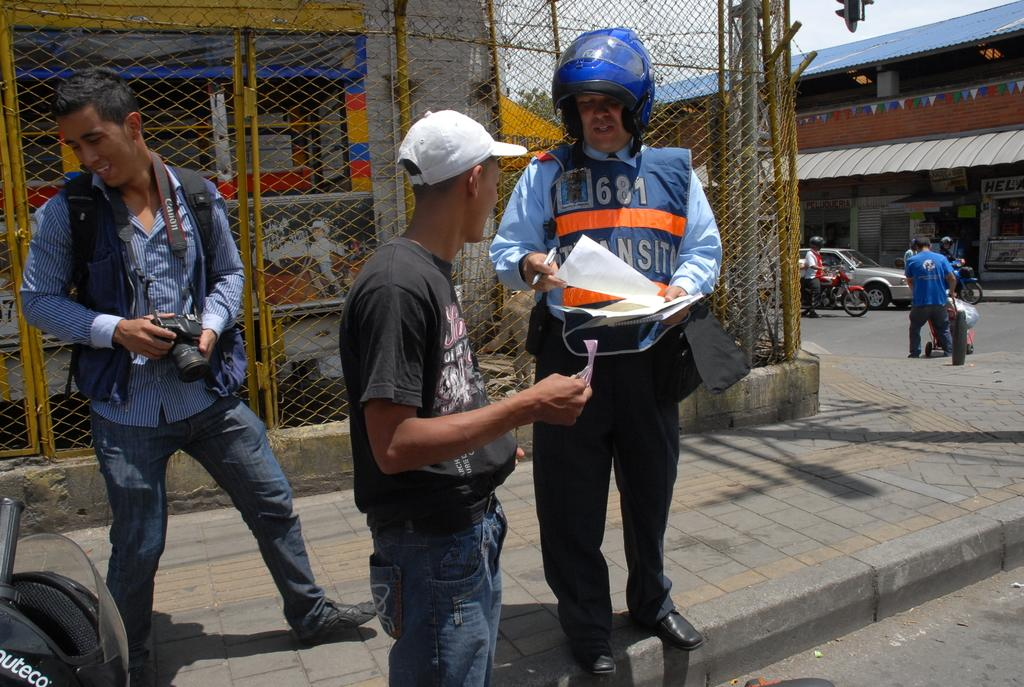What are the people in the image doing? The persons standing on the road are likely waiting or walking. What else can be seen on the road besides the people? Motor vehicles are present in the image. What type of barrier is visible in the image? There is an iron grill in the image. What is the purpose of the footpath in the image? The footpath is meant for pedestrians to walk on. What type of structures can be seen in the image? There are buildings and a shed in the image. What type of vegetation is present in the image? Trees are present in the image. What is visible in the background of the image? The sky is visible in the image. Where is the cemetery located in the image? There is no cemetery present in the image. What type of dinosaurs can be seen roaming around in the image? There are no dinosaurs present in the image. 